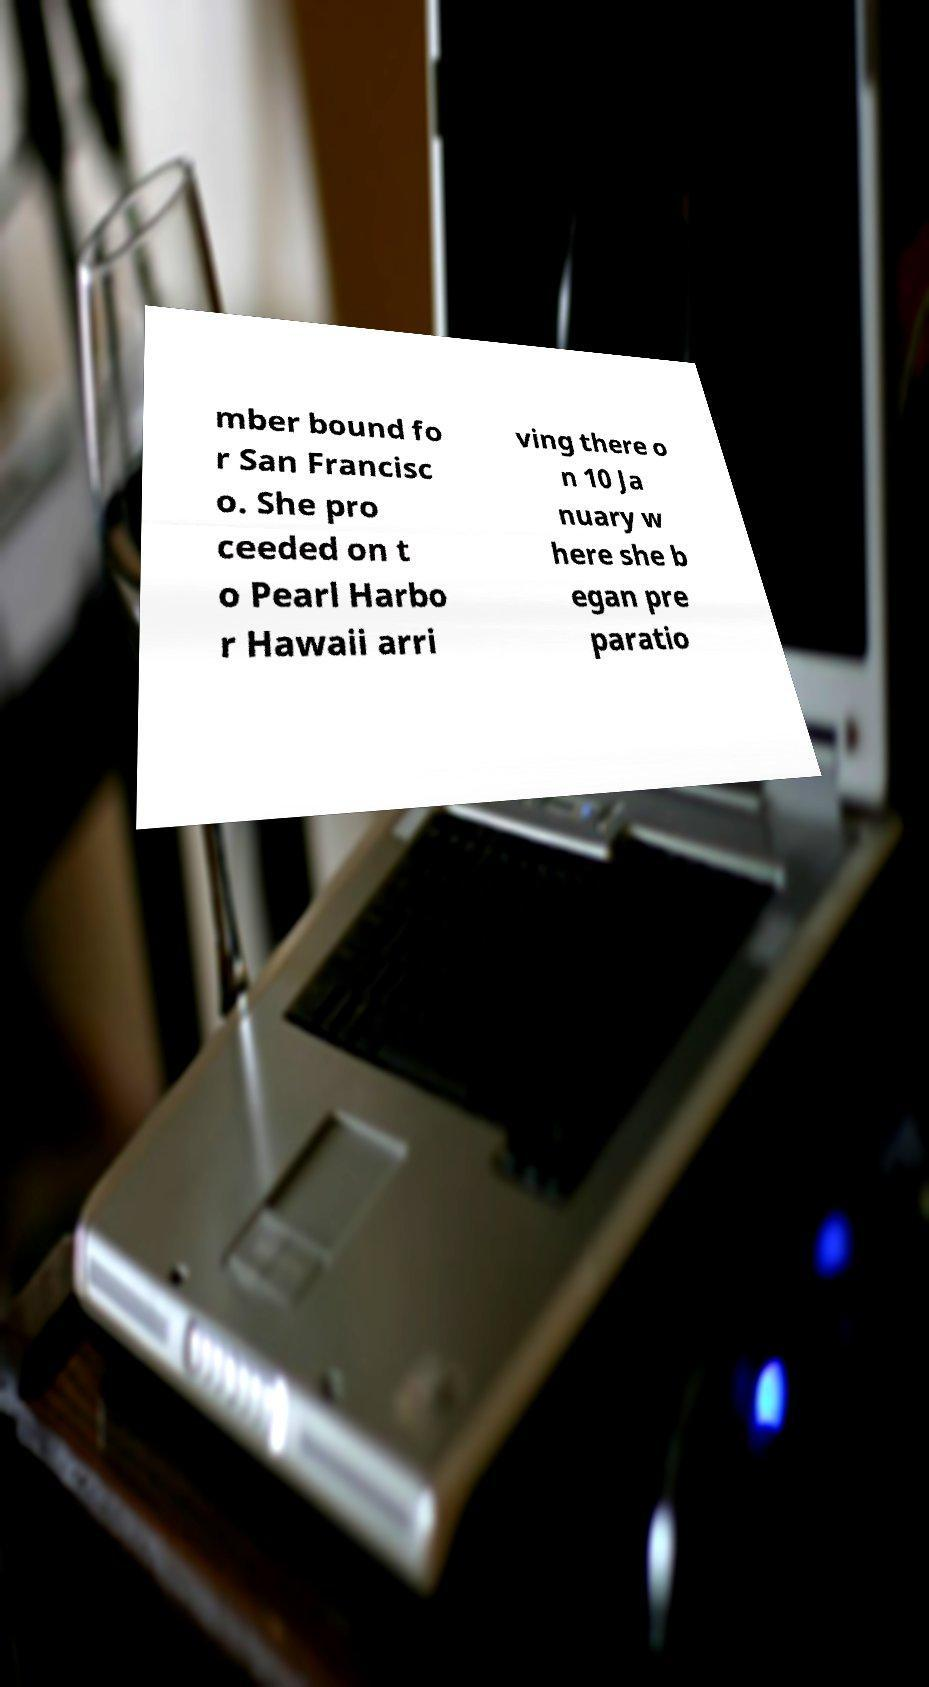Could you extract and type out the text from this image? mber bound fo r San Francisc o. She pro ceeded on t o Pearl Harbo r Hawaii arri ving there o n 10 Ja nuary w here she b egan pre paratio 